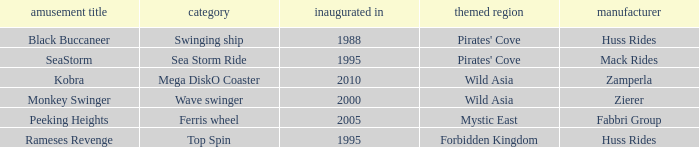What category of ride does rameses revenge belong to? Top Spin. 